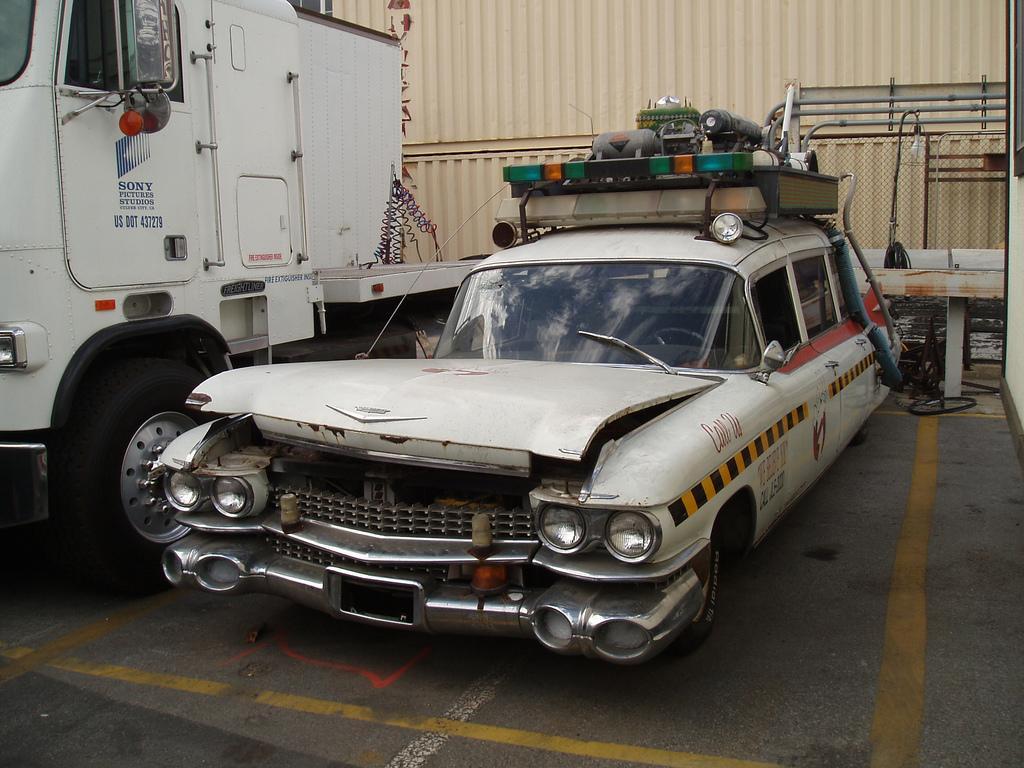In one or two sentences, can you explain what this image depicts? These are the vehicles, which are parked. I can see few objects, which are kept at the top of a car. In the background, that looks like an iron container. 